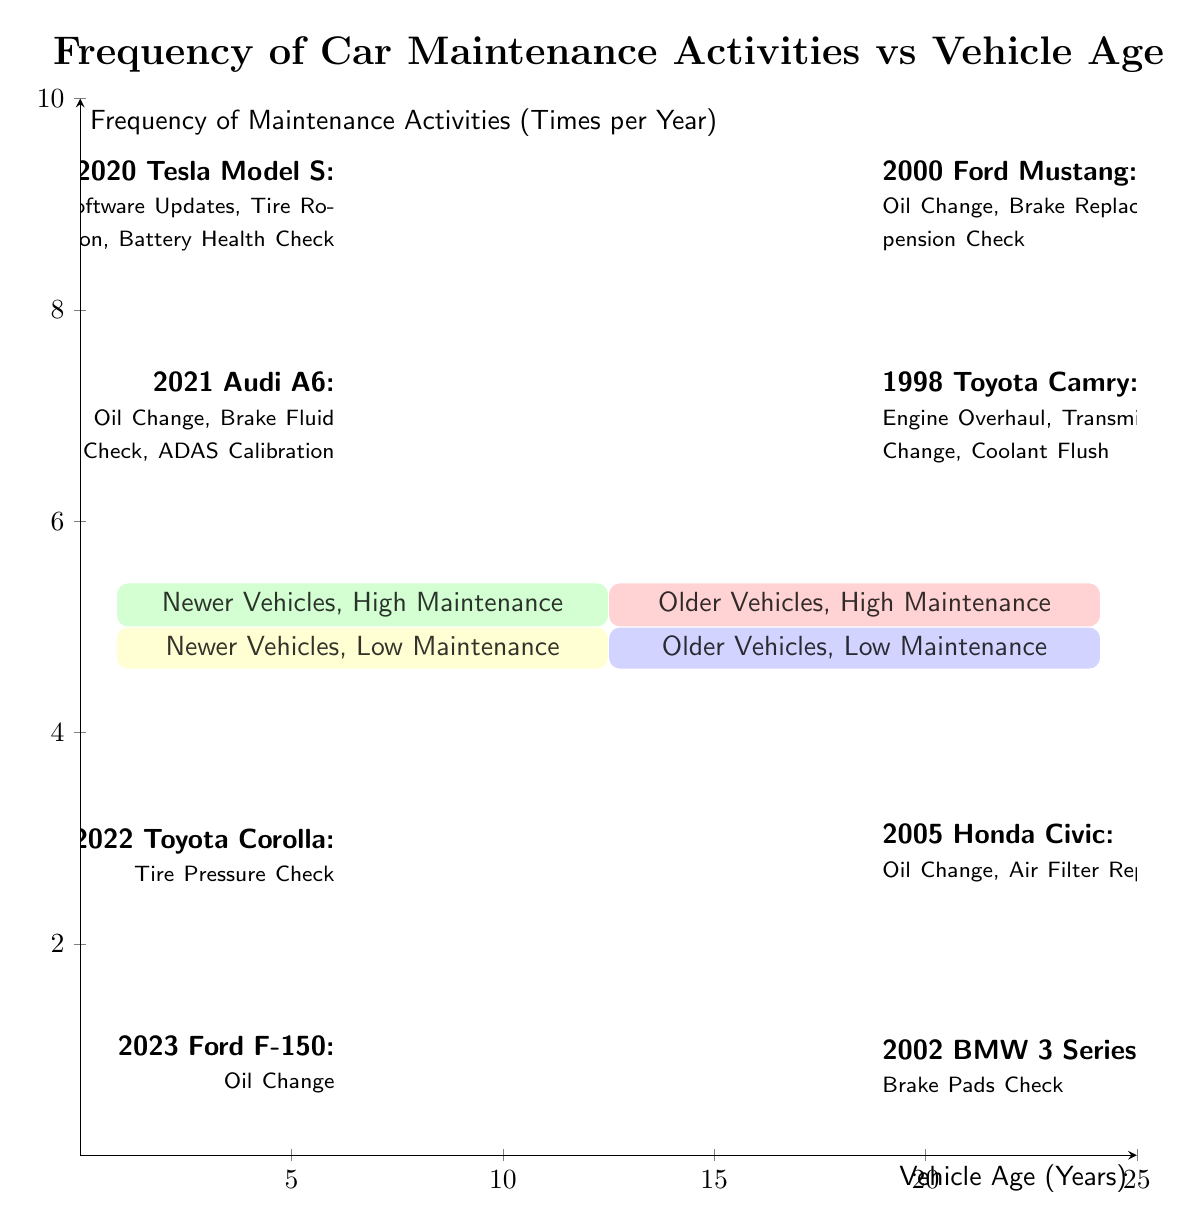What are the two characteristics of the TopRight quadrant? The TopRight quadrant is labeled "Older Vehicles, High Maintenance". It indicates that vehicles in this area are both older and require high frequency of maintenance activities per year.
Answer: Older Vehicles, High Maintenance How many maintenance activities does the 2020 Tesla Model S require? The 2020 Tesla Model S is listed in the TopLeft quadrant with three maintenance activities: Software Updates, Tire Rotation, and Battery Health Check. Thus, it requires three maintenance activities in total.
Answer: Three Which vehicle in the BottomLeft quadrant has the lowest maintenance? The 2022 Toyota Corolla in the BottomLeft quadrant has the lowest maintenance with only one activity: Tire Pressure Check.
Answer: 2022 Toyota Corolla What is the main difference between vehicles in the TopLeft and BottomLeft quadrants? Vehicles in the TopLeft quadrant are newer and have high maintenance frequency, while vehicles in the BottomLeft quadrant are also newer but have low maintenance frequency. This reflects the contrast in the amount of maintenance activities performed.
Answer: Newer, High Maintenance vs. Newer, Low Maintenance Which vehicle is an example of "Older Vehicles, Low Maintenance"? In the BottomRight quadrant, the 2005 Honda Civic is indicated as an example of "Older Vehicles, Low Maintenance," featuring activities such as Oil Change and Air Filter Replacement.
Answer: 2005 Honda Civic How many examples of vehicles are found in the TopRight quadrant? There are two examples of vehicles in the TopRight quadrant of the chart: the 2000 Ford Mustang and the 1998 Toyota Camry, which require high maintenance.
Answer: Two What is the distinction between the maintenance frequency of newer versus older vehicles in the TopLeft quadrant? In the TopLeft quadrant, newer vehicles still have high maintenance frequency, reflecting that modern vehicles can require frequent updates and checks compared to older vehicles, which are found in the TopRight quadrant. The newer vehicles often have complex systems needing regular attention despite their age classification.
Answer: High Maintenance Which quadrant contains newer vehicles but requires fewer maintenance activities? The BottomLeft quadrant contains newer vehicles while requiring low maintenance activities, as indicated by the examples provided.
Answer: BottomLeft What maintenance activity is common for both the 2005 Honda Civic and the 2002 BMW 3 Series? Both the 2005 Honda Civic and the 2002 BMW 3 Series, found in the BottomRight quadrant, perform an Oil Change as part of their maintenance activities.
Answer: Oil Change 